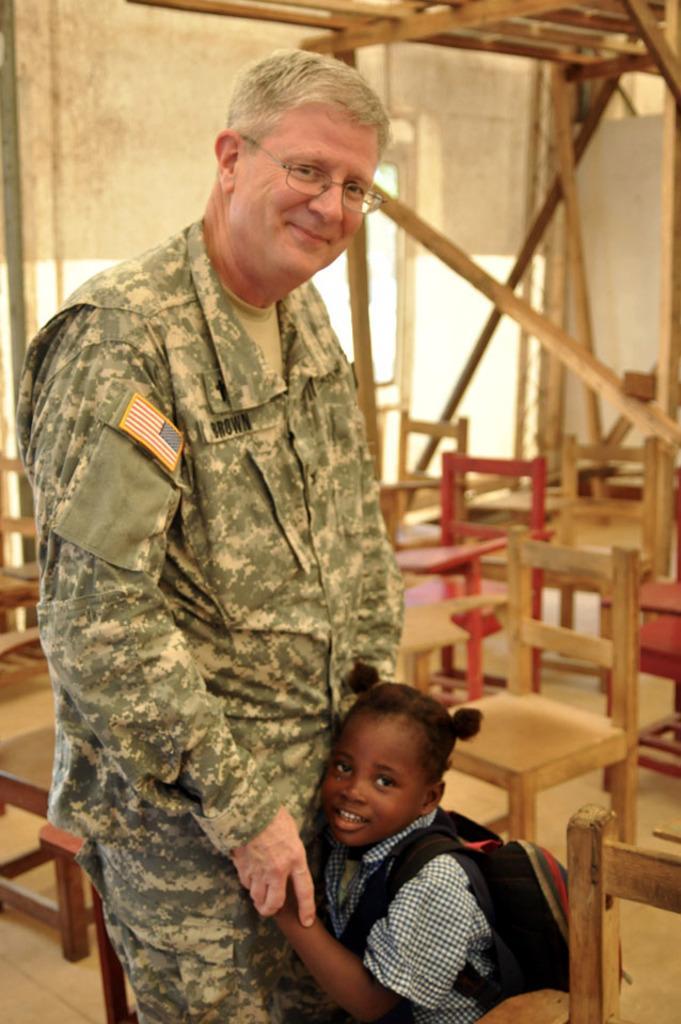Could you give a brief overview of what you see in this image? In the picture we can see a man and a girl child standing together and man is in army dress and behind them we can see some chairs. 